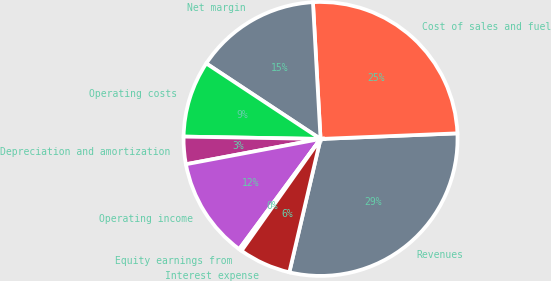Convert chart to OTSL. <chart><loc_0><loc_0><loc_500><loc_500><pie_chart><fcel>Revenues<fcel>Cost of sales and fuel<fcel>Net margin<fcel>Operating costs<fcel>Depreciation and amortization<fcel>Operating income<fcel>Equity earnings from<fcel>Interest expense<nl><fcel>29.31%<fcel>25.23%<fcel>14.82%<fcel>9.02%<fcel>3.23%<fcel>11.92%<fcel>0.33%<fcel>6.13%<nl></chart> 